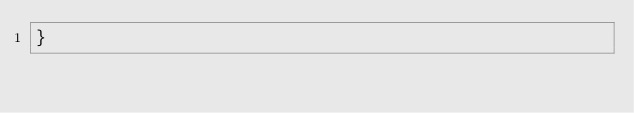Convert code to text. <code><loc_0><loc_0><loc_500><loc_500><_PHP_>}
</code> 